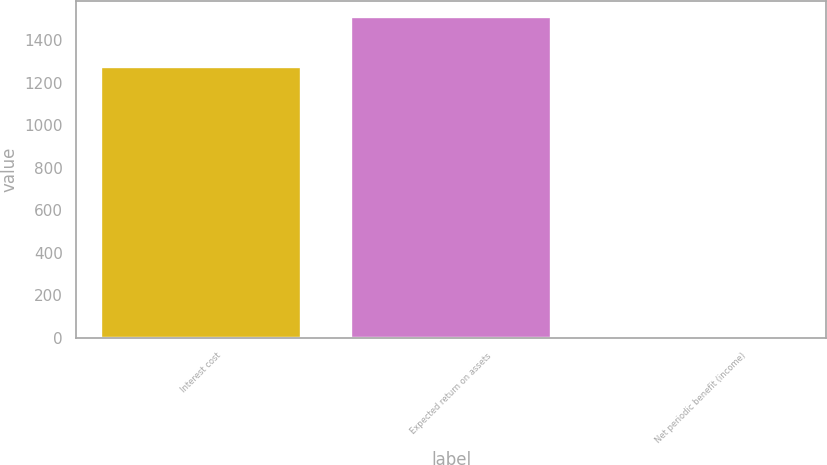Convert chart to OTSL. <chart><loc_0><loc_0><loc_500><loc_500><bar_chart><fcel>Interest cost<fcel>Expected return on assets<fcel>Net periodic benefit (income)<nl><fcel>1274<fcel>1510<fcel>9<nl></chart> 